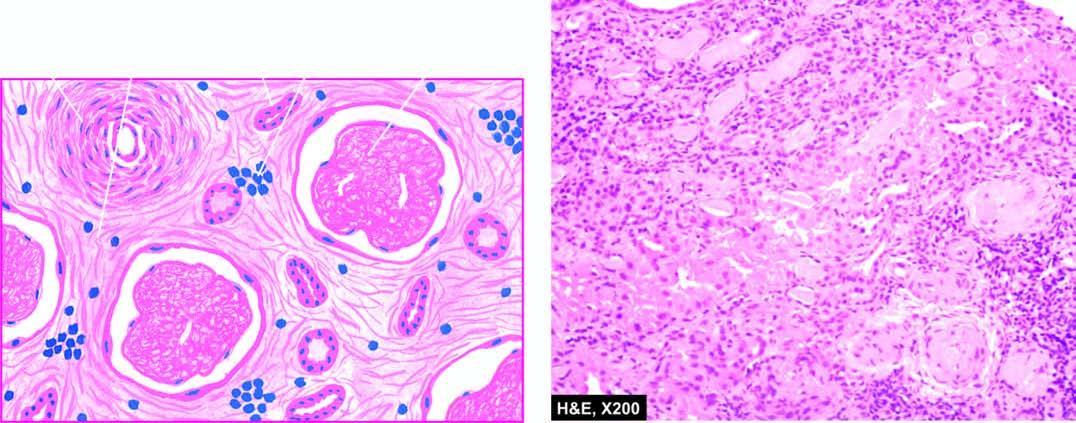what shows fine fibrosis and a few chronic inflammatory cells?
Answer the question using a single word or phrase. Interstitium 